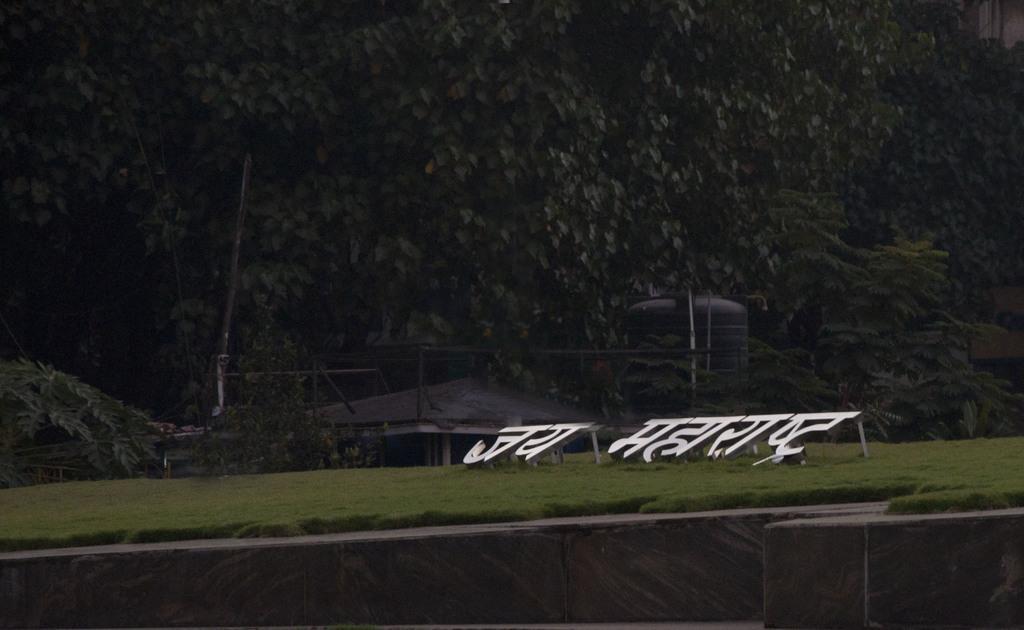Please provide a concise description of this image. In this picture we can observe a text in Hindi on the ground. We can observe a black color water tank. In the background there are trees. 